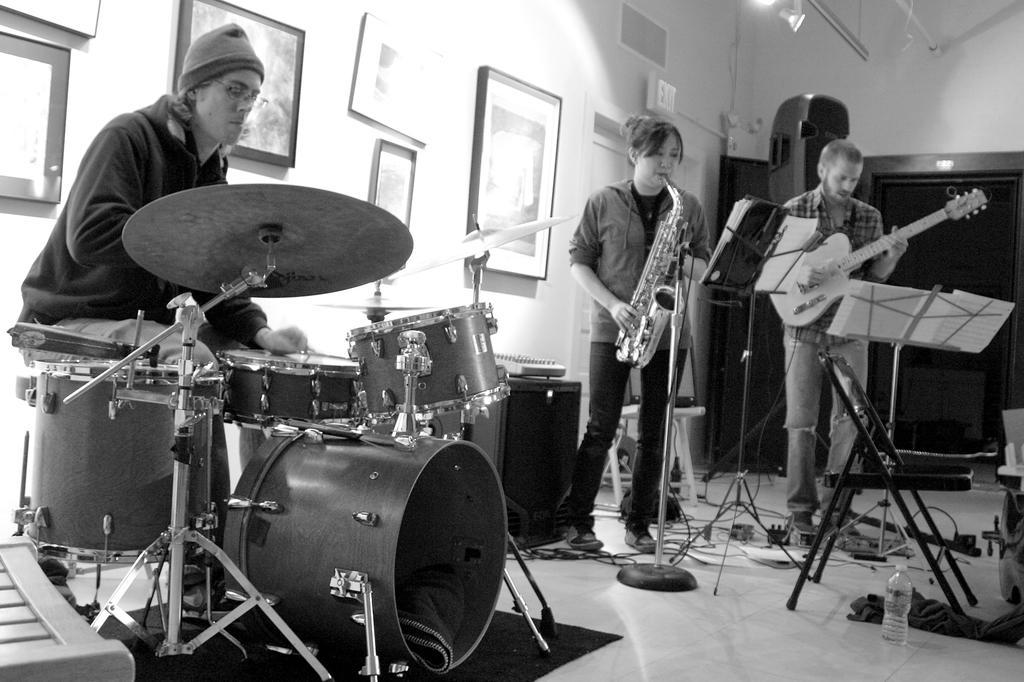In one or two sentences, can you explain what this image depicts? This is a black and white picture. We can see photo frames over a wall. This is a light. this is a door. Here we can see persons sitting and standing , playing musical instruments. This is a floor and we can see water bottle on the floor. 